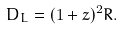Convert formula to latex. <formula><loc_0><loc_0><loc_500><loc_500>D _ { L } = ( 1 + z ) ^ { 2 } R .</formula> 